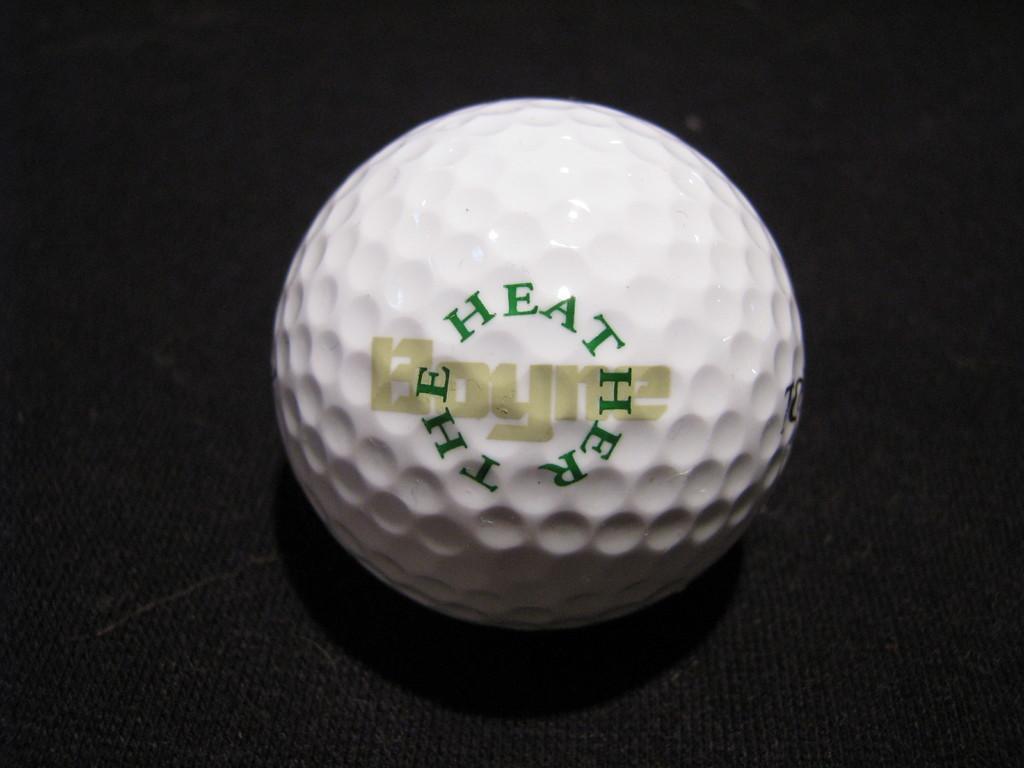Could you give a brief overview of what you see in this image? In this picture there is a golf ball on a black surface. 